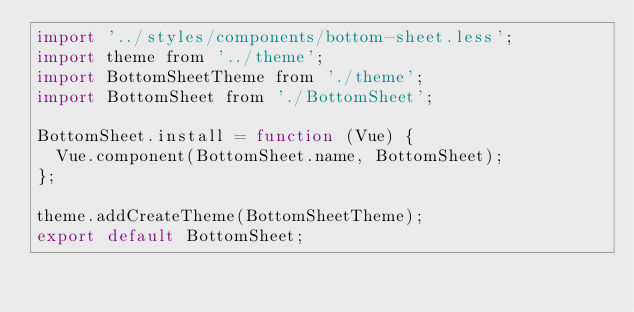<code> <loc_0><loc_0><loc_500><loc_500><_JavaScript_>import '../styles/components/bottom-sheet.less';
import theme from '../theme';
import BottomSheetTheme from './theme';
import BottomSheet from './BottomSheet';

BottomSheet.install = function (Vue) {
  Vue.component(BottomSheet.name, BottomSheet);
};

theme.addCreateTheme(BottomSheetTheme);
export default BottomSheet;
</code> 